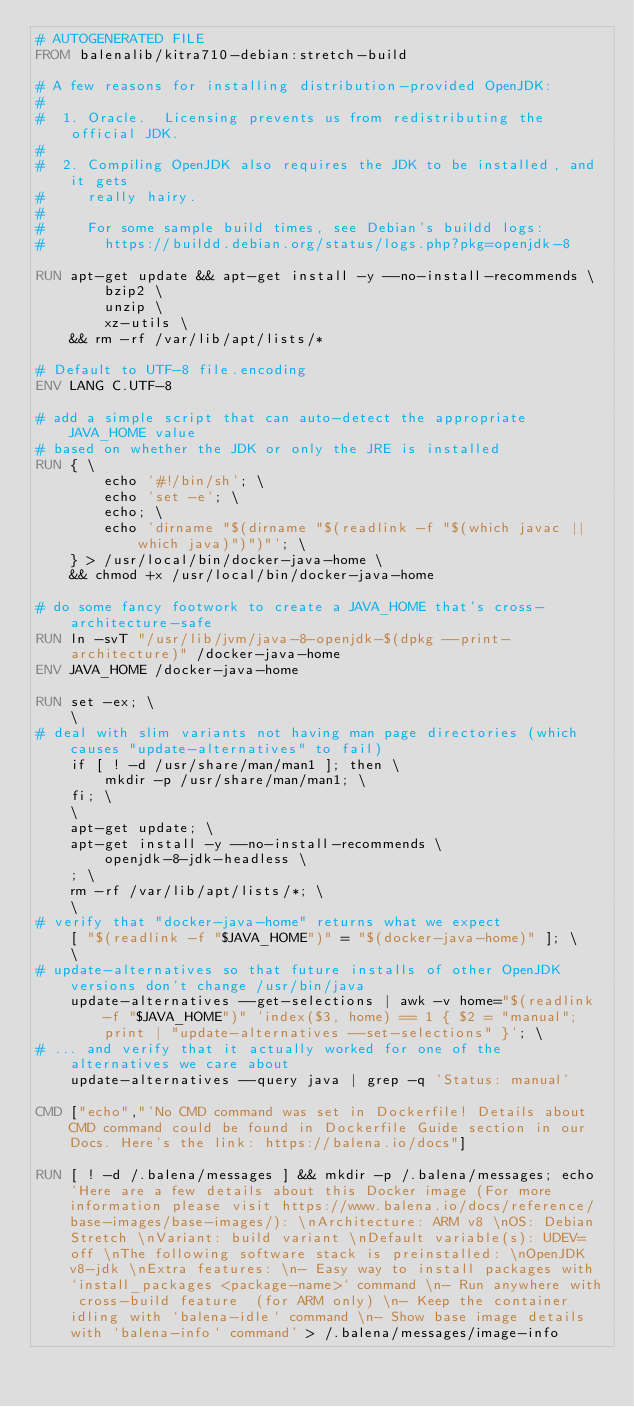Convert code to text. <code><loc_0><loc_0><loc_500><loc_500><_Dockerfile_># AUTOGENERATED FILE
FROM balenalib/kitra710-debian:stretch-build

# A few reasons for installing distribution-provided OpenJDK:
#
#  1. Oracle.  Licensing prevents us from redistributing the official JDK.
#
#  2. Compiling OpenJDK also requires the JDK to be installed, and it gets
#     really hairy.
#
#     For some sample build times, see Debian's buildd logs:
#       https://buildd.debian.org/status/logs.php?pkg=openjdk-8

RUN apt-get update && apt-get install -y --no-install-recommends \
		bzip2 \
		unzip \
		xz-utils \
	&& rm -rf /var/lib/apt/lists/*

# Default to UTF-8 file.encoding
ENV LANG C.UTF-8

# add a simple script that can auto-detect the appropriate JAVA_HOME value
# based on whether the JDK or only the JRE is installed
RUN { \
		echo '#!/bin/sh'; \
		echo 'set -e'; \
		echo; \
		echo 'dirname "$(dirname "$(readlink -f "$(which javac || which java)")")"'; \
	} > /usr/local/bin/docker-java-home \
	&& chmod +x /usr/local/bin/docker-java-home

# do some fancy footwork to create a JAVA_HOME that's cross-architecture-safe
RUN ln -svT "/usr/lib/jvm/java-8-openjdk-$(dpkg --print-architecture)" /docker-java-home
ENV JAVA_HOME /docker-java-home

RUN set -ex; \
	\
# deal with slim variants not having man page directories (which causes "update-alternatives" to fail)
	if [ ! -d /usr/share/man/man1 ]; then \
		mkdir -p /usr/share/man/man1; \
	fi; \
	\
	apt-get update; \
	apt-get install -y --no-install-recommends \
		openjdk-8-jdk-headless \
	; \
	rm -rf /var/lib/apt/lists/*; \
	\
# verify that "docker-java-home" returns what we expect
	[ "$(readlink -f "$JAVA_HOME")" = "$(docker-java-home)" ]; \
	\
# update-alternatives so that future installs of other OpenJDK versions don't change /usr/bin/java
	update-alternatives --get-selections | awk -v home="$(readlink -f "$JAVA_HOME")" 'index($3, home) == 1 { $2 = "manual"; print | "update-alternatives --set-selections" }'; \
# ... and verify that it actually worked for one of the alternatives we care about
	update-alternatives --query java | grep -q 'Status: manual'

CMD ["echo","'No CMD command was set in Dockerfile! Details about CMD command could be found in Dockerfile Guide section in our Docs. Here's the link: https://balena.io/docs"]

RUN [ ! -d /.balena/messages ] && mkdir -p /.balena/messages; echo 'Here are a few details about this Docker image (For more information please visit https://www.balena.io/docs/reference/base-images/base-images/): \nArchitecture: ARM v8 \nOS: Debian Stretch \nVariant: build variant \nDefault variable(s): UDEV=off \nThe following software stack is preinstalled: \nOpenJDK v8-jdk \nExtra features: \n- Easy way to install packages with `install_packages <package-name>` command \n- Run anywhere with cross-build feature  (for ARM only) \n- Keep the container idling with `balena-idle` command \n- Show base image details with `balena-info` command' > /.balena/messages/image-info</code> 